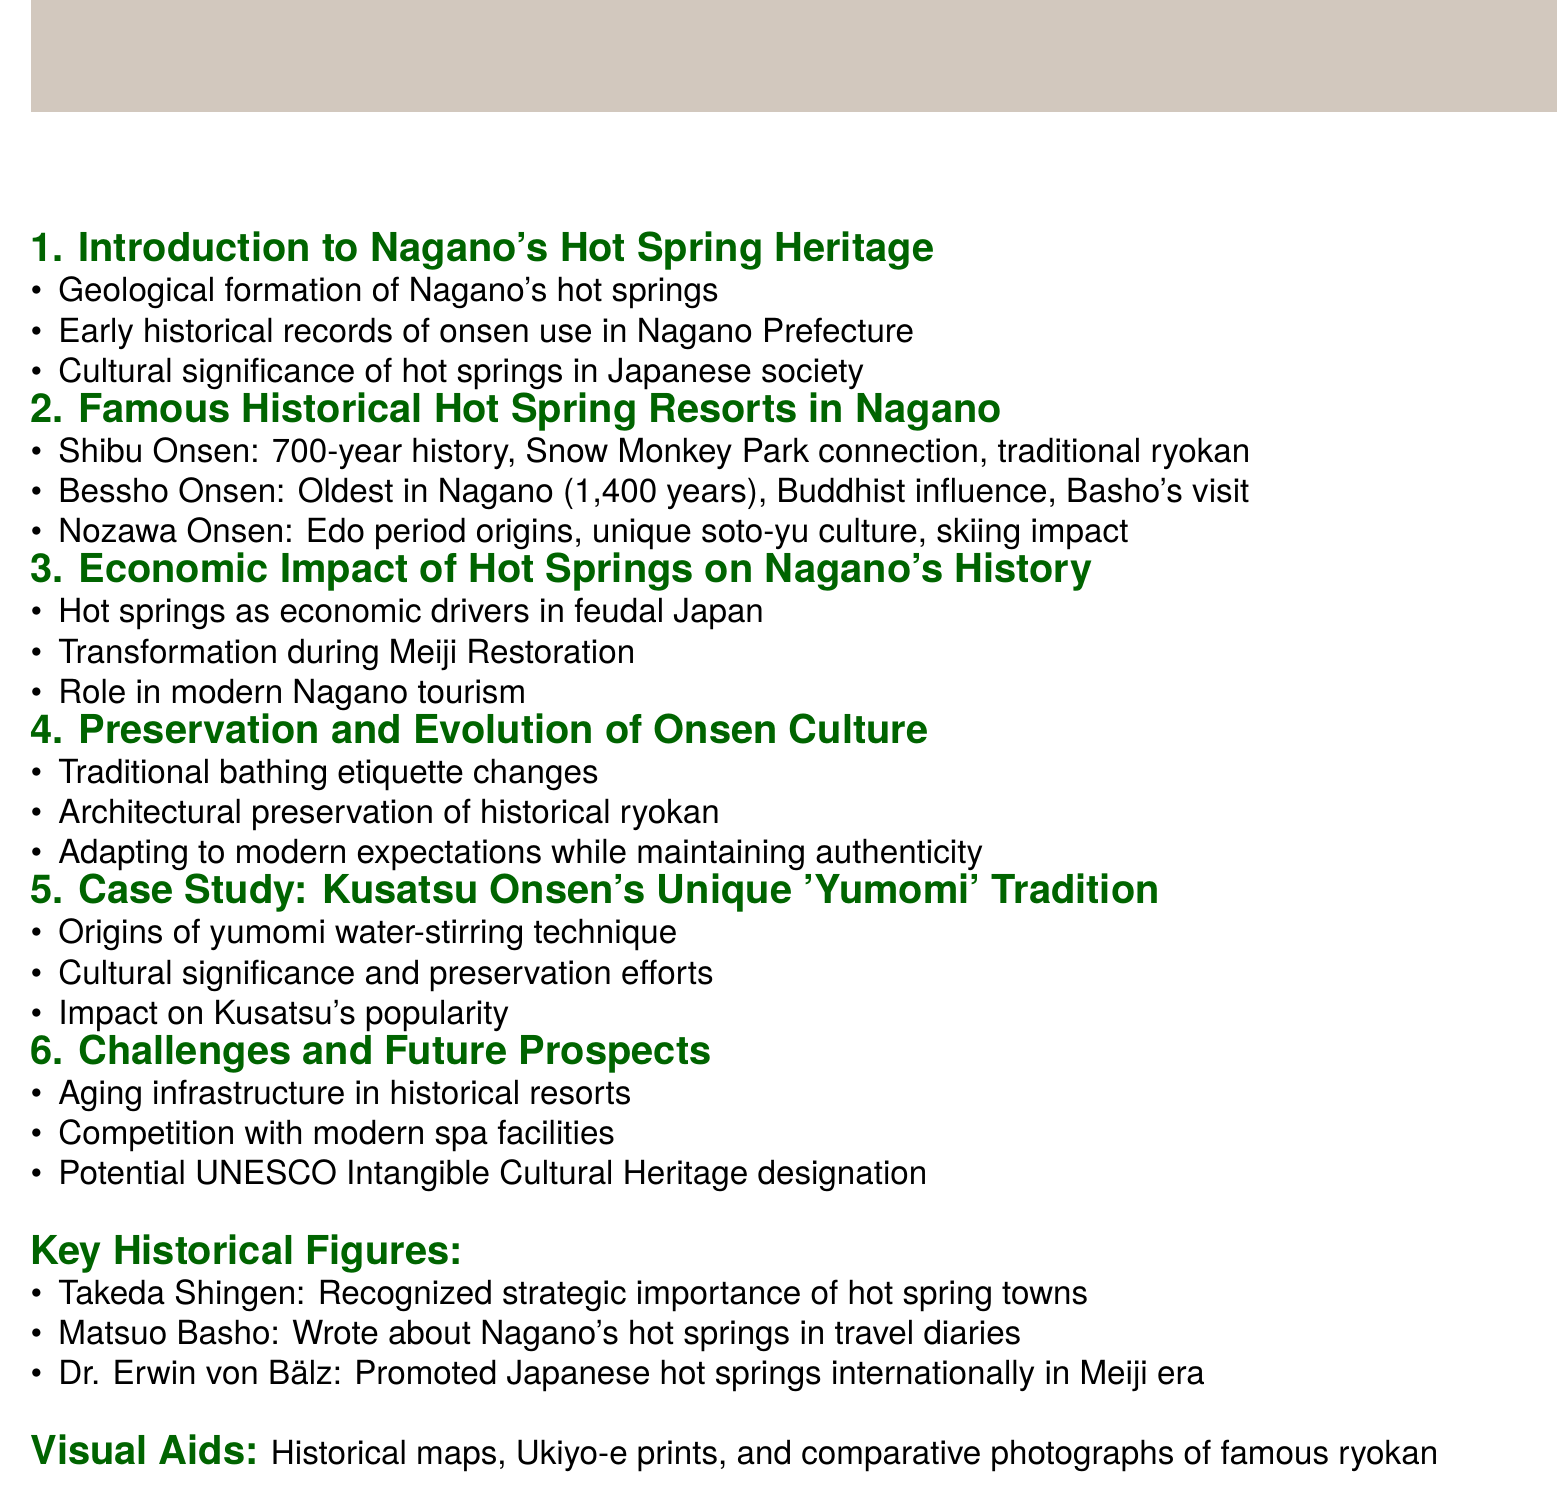What is the oldest hot spring in Nagano? The document states that Bessho Onsen is the oldest hot spring in Nagano, with a history of 1,400 years.
Answer: Bessho Onsen How many years of history does Shibu Onsen have? The document mentions that Shibu Onsen has a history of 700 years.
Answer: 700 years Which key historical figure wrote about Nagano's hot springs? Matsuo Basho is identified in the document as the poet who wrote about Nagano's hot springs in his travel diaries.
Answer: Matsuo Basho What is the unique bathing culture referenced in the document? The document highlights the unique soto-yu culture associated with Nozawa Onsen.
Answer: soto-yu What potential designation is mentioned in relation to the future of Nagano's hot springs? The document discusses the potential for UNESCO Intangible Cultural Heritage designation for Nagano's hot springs.
Answer: UNESCO Intangible Cultural Heritage What art form is included as visual aid in the document? Ukiyo-e prints depicting bathing scenes are mentioned as a visual aid to be included in the presentation.
Answer: Ukiyo-e prints 